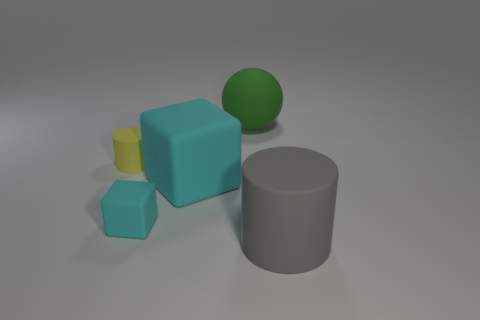Is the size of the gray matte object the same as the ball?
Give a very brief answer. Yes. There is a cyan object that is the same size as the gray cylinder; what shape is it?
Make the answer very short. Cube. Do the matte cylinder that is behind the gray cylinder and the tiny block have the same size?
Your answer should be compact. Yes. There is a cyan cube that is the same size as the rubber ball; what is it made of?
Make the answer very short. Rubber. Are there any big gray cylinders that are behind the big object that is to the right of the thing that is behind the small yellow rubber cylinder?
Keep it short and to the point. No. Are there any other things that are the same shape as the large green thing?
Keep it short and to the point. No. Does the object behind the small yellow object have the same color as the cylinder that is to the left of the big cylinder?
Your answer should be very brief. No. Are there any small blue metallic balls?
Provide a succinct answer. No. What is the material of the small thing that is the same color as the big block?
Keep it short and to the point. Rubber. What is the size of the thing behind the rubber cylinder that is behind the big object on the right side of the big green matte thing?
Give a very brief answer. Large. 